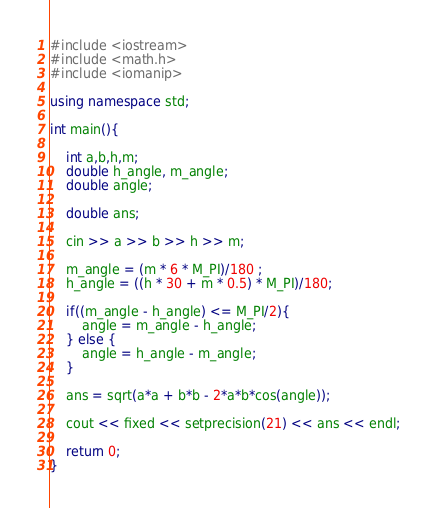Convert code to text. <code><loc_0><loc_0><loc_500><loc_500><_C++_>#include <iostream>
#include <math.h>
#include <iomanip>

using namespace std;

int main(){

	int a,b,h,m;
	double h_angle, m_angle;
	double angle;
	
	double ans;

	cin >> a >> b >> h >> m;

	m_angle = (m * 6 * M_PI)/180 ;
	h_angle = ((h * 30 + m * 0.5) * M_PI)/180;

	if((m_angle - h_angle) <= M_PI/2){
		angle = m_angle - h_angle;
	} else {
		angle = h_angle - m_angle;
	}

	ans = sqrt(a*a + b*b - 2*a*b*cos(angle));

	cout << fixed << setprecision(21) << ans << endl;

	return 0;
}
</code> 